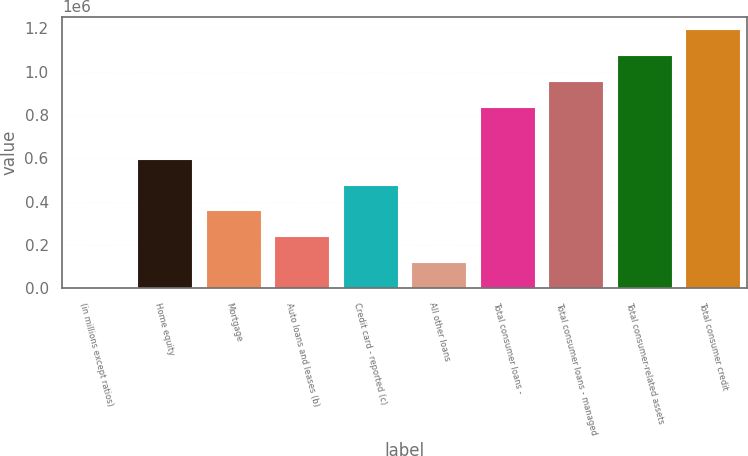Convert chart. <chart><loc_0><loc_0><loc_500><loc_500><bar_chart><fcel>(in millions except ratios)<fcel>Home equity<fcel>Mortgage<fcel>Auto loans and leases (b)<fcel>Credit card - reported (c)<fcel>All other loans<fcel>Total consumer loans -<fcel>Total consumer loans - managed<fcel>Total consumer-related assets<fcel>Total consumer credit<nl><fcel>2007<fcel>598471<fcel>359885<fcel>240593<fcel>479178<fcel>121300<fcel>837057<fcel>956349<fcel>1.07564e+06<fcel>1.19494e+06<nl></chart> 